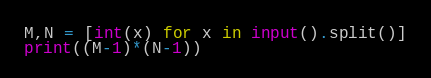Convert code to text. <code><loc_0><loc_0><loc_500><loc_500><_Python_>M,N = [int(x) for x in input().split()]
print((M-1)*(N-1))</code> 